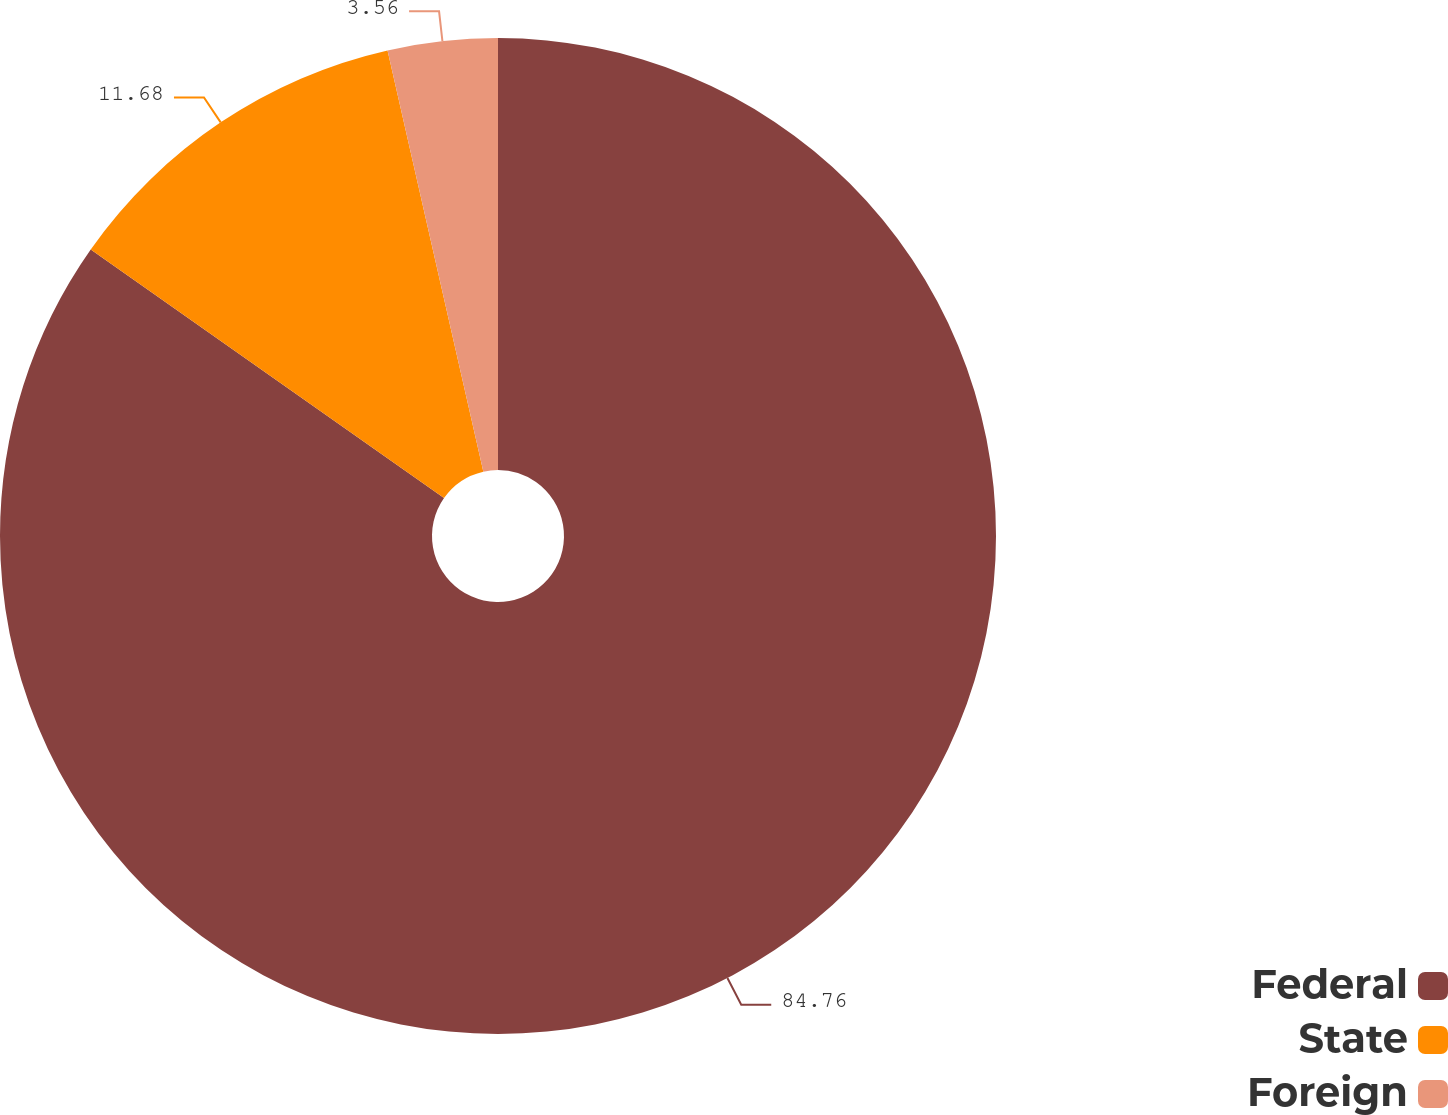<chart> <loc_0><loc_0><loc_500><loc_500><pie_chart><fcel>Federal<fcel>State<fcel>Foreign<nl><fcel>84.76%<fcel>11.68%<fcel>3.56%<nl></chart> 